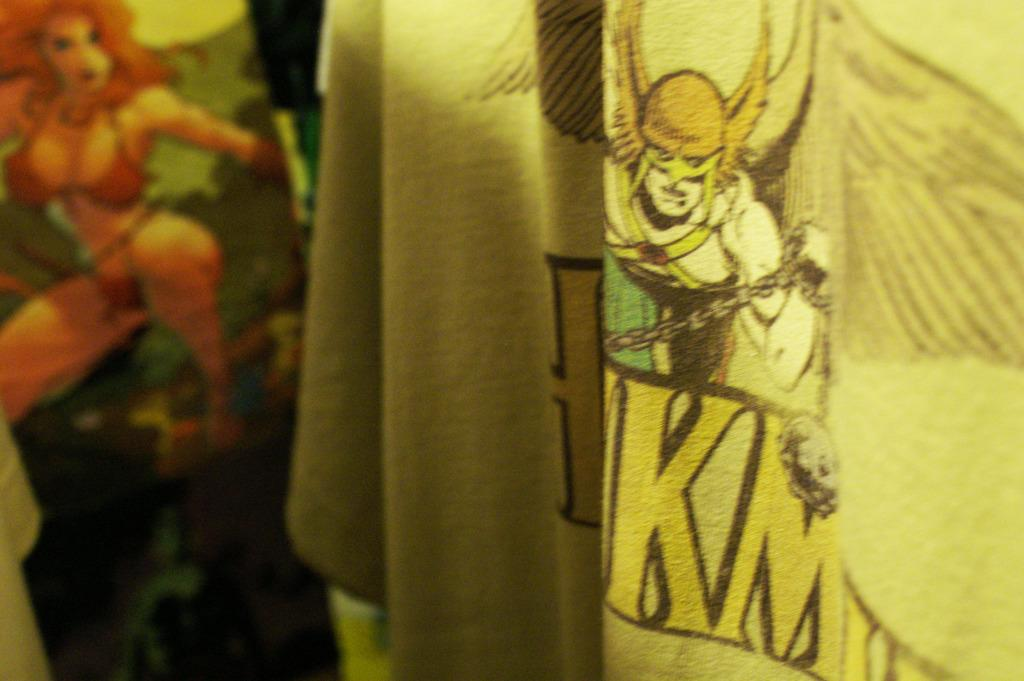How many clothes are visible in the image? There are two clothes in the image. Where are the clothes located in the image? The clothes are on the right and left sides of the image. What is depicted on the clothes? The clothes have cartoon characters on them. What is the father's role in the image? There is no father present in the image, as it only features two clothes with cartoon characters on them. 